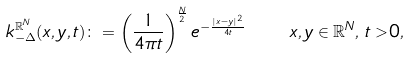<formula> <loc_0><loc_0><loc_500><loc_500>k _ { - \Delta } ^ { \mathbb { R } ^ { N } } ( x , y , t ) \colon = \left ( \frac { 1 } { 4 \pi t } \right ) ^ { \frac { N } { 2 } } e ^ { - \frac { | x - y | ^ { 2 } } { 4 t } } \quad x , y \in \mathbb { R } ^ { N } , \, t > 0 ,</formula> 